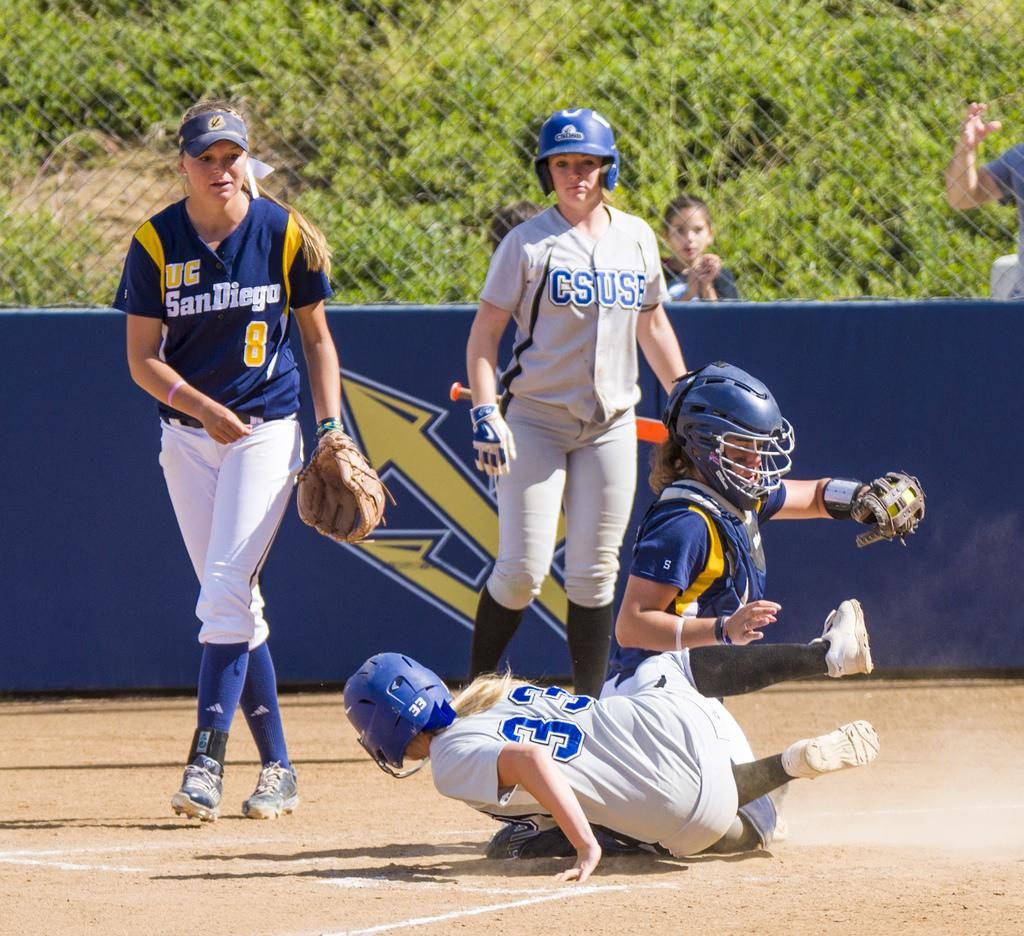<image>
Summarize the visual content of the image. A girls' baseball game involves two competing college teams, one from UC San Diego and the other from Cal State University San Bernardino. 